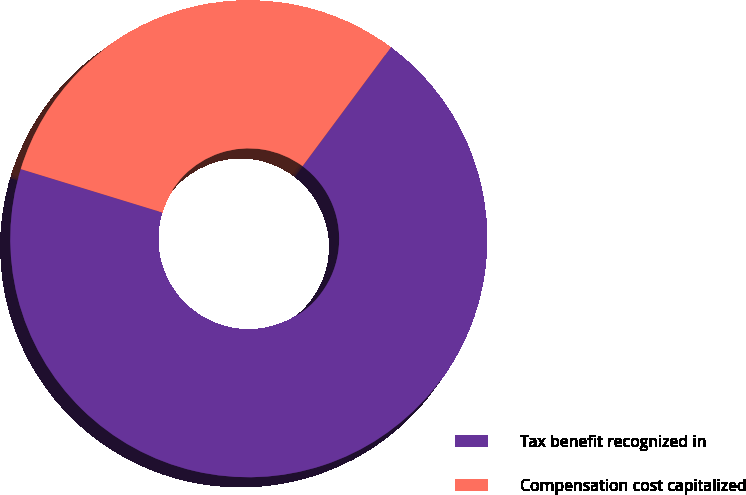<chart> <loc_0><loc_0><loc_500><loc_500><pie_chart><fcel>Tax benefit recognized in<fcel>Compensation cost capitalized<nl><fcel>69.57%<fcel>30.43%<nl></chart> 